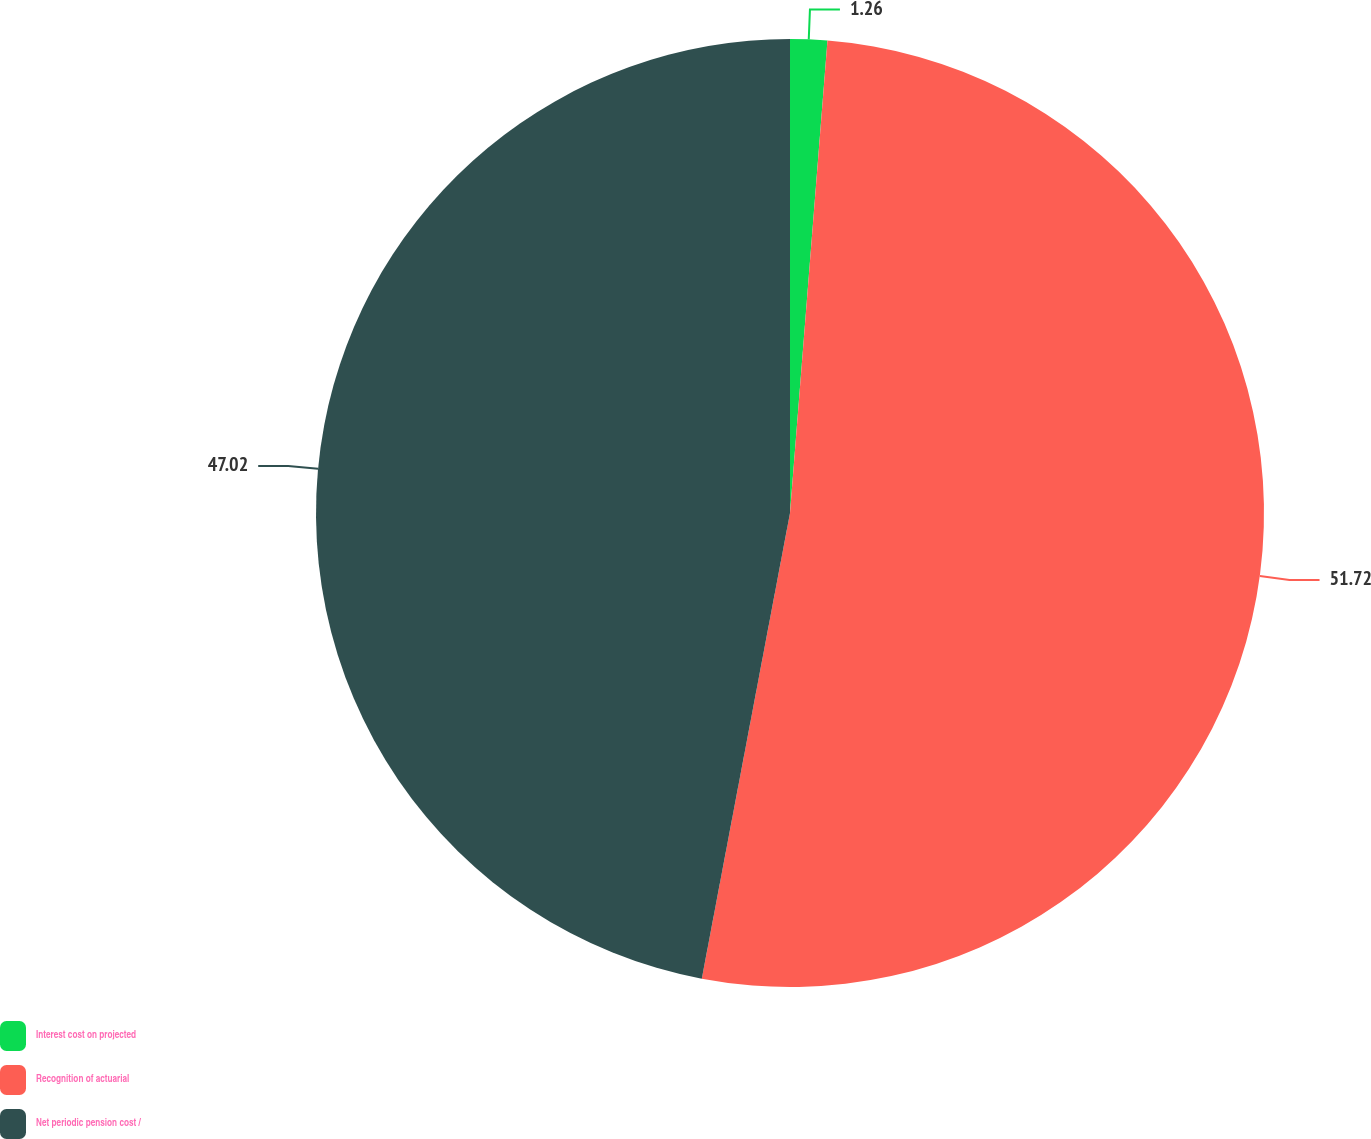Convert chart. <chart><loc_0><loc_0><loc_500><loc_500><pie_chart><fcel>Interest cost on projected<fcel>Recognition of actuarial<fcel>Net periodic pension cost /<nl><fcel>1.26%<fcel>51.72%<fcel>47.02%<nl></chart> 